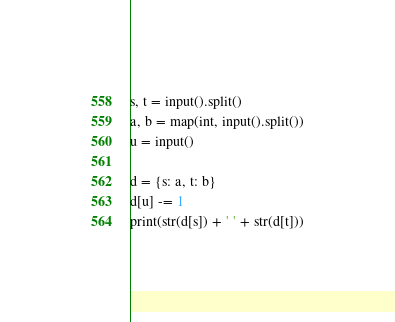<code> <loc_0><loc_0><loc_500><loc_500><_Python_>s, t = input().split()
a, b = map(int, input().split())
u = input()

d = {s: a, t: b}
d[u] -= 1
print(str(d[s]) + ' ' + str(d[t]))
</code> 